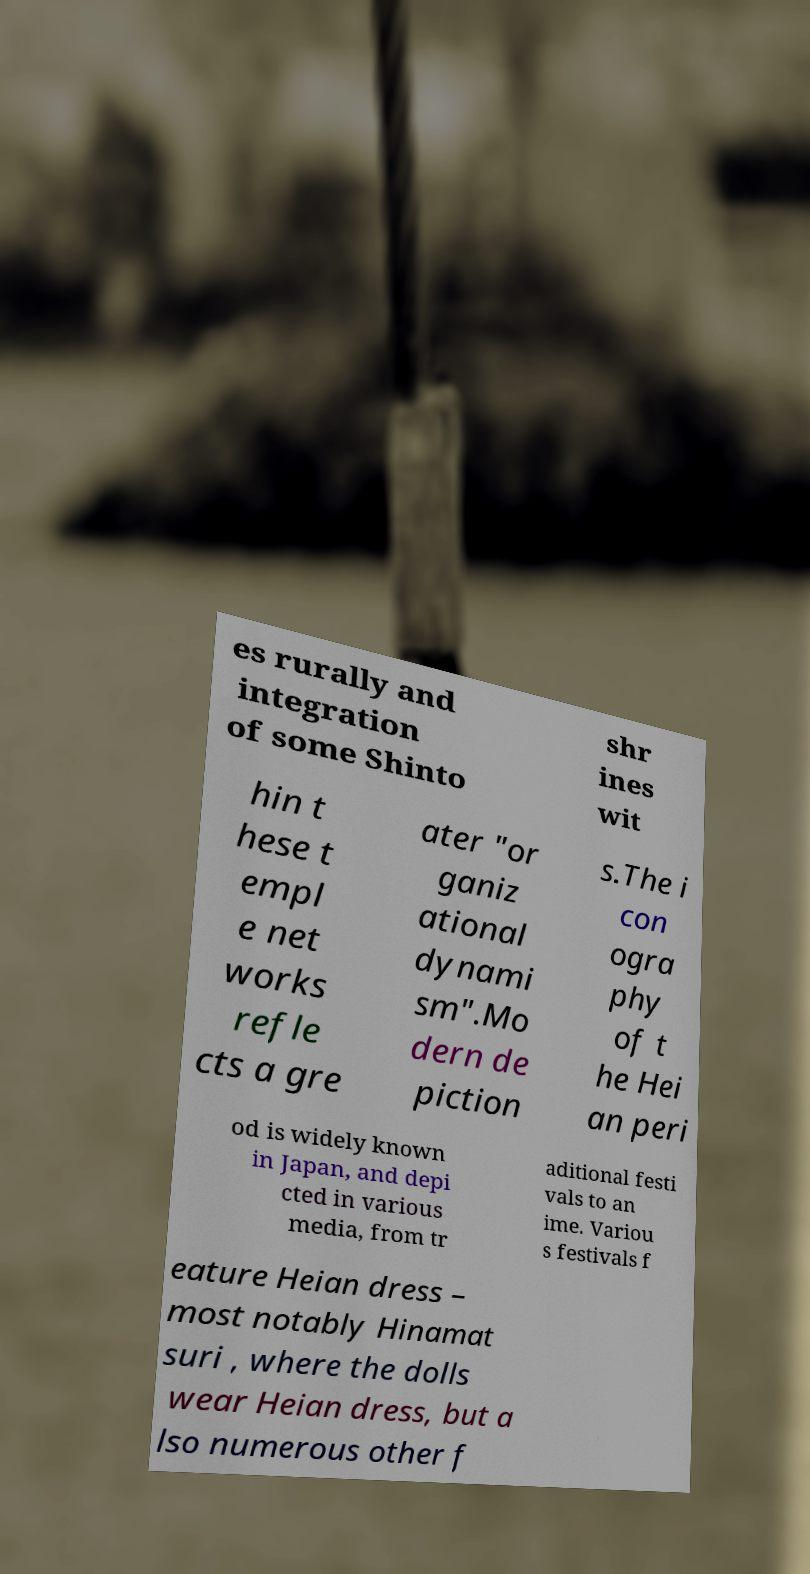Please read and relay the text visible in this image. What does it say? es rurally and integration of some Shinto shr ines wit hin t hese t empl e net works refle cts a gre ater "or ganiz ational dynami sm".Mo dern de piction s.The i con ogra phy of t he Hei an peri od is widely known in Japan, and depi cted in various media, from tr aditional festi vals to an ime. Variou s festivals f eature Heian dress – most notably Hinamat suri , where the dolls wear Heian dress, but a lso numerous other f 